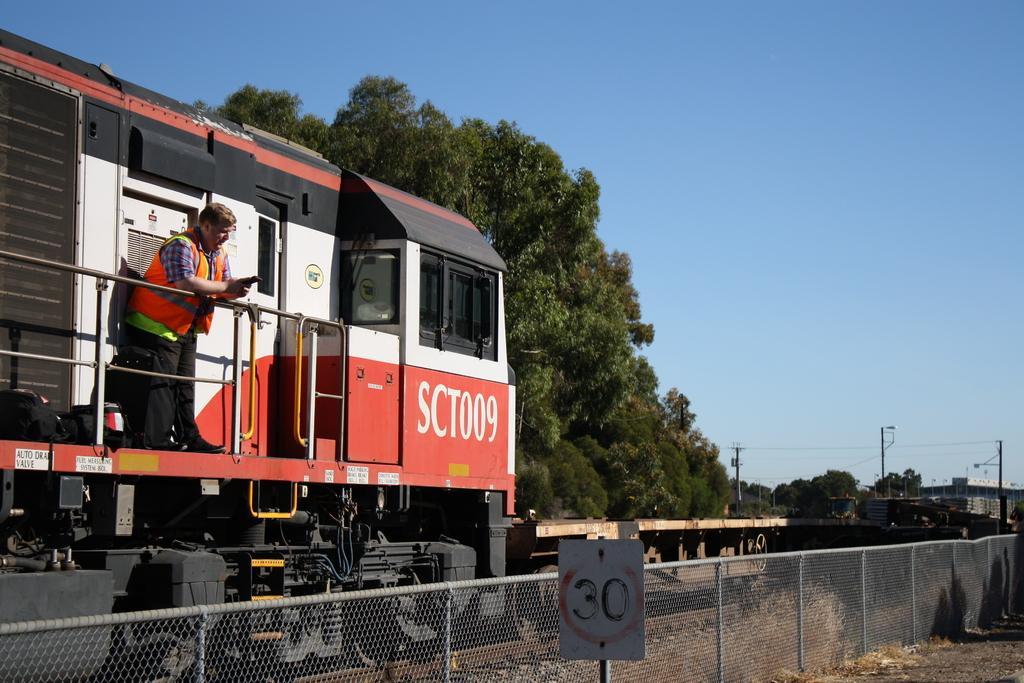How would you summarize this image in a sentence or two? In this image, at the left side we can see a train, there is a man standing in a train, there is a fencing and there are some green color trees, at the top there is a blue color sky. 